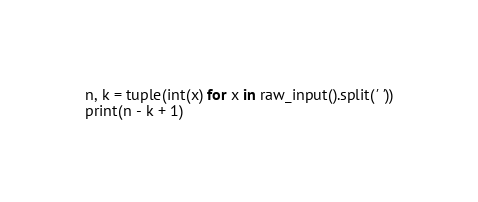<code> <loc_0><loc_0><loc_500><loc_500><_Python_>n, k = tuple(int(x) for x in raw_input().split(' '))
print(n - k + 1)</code> 